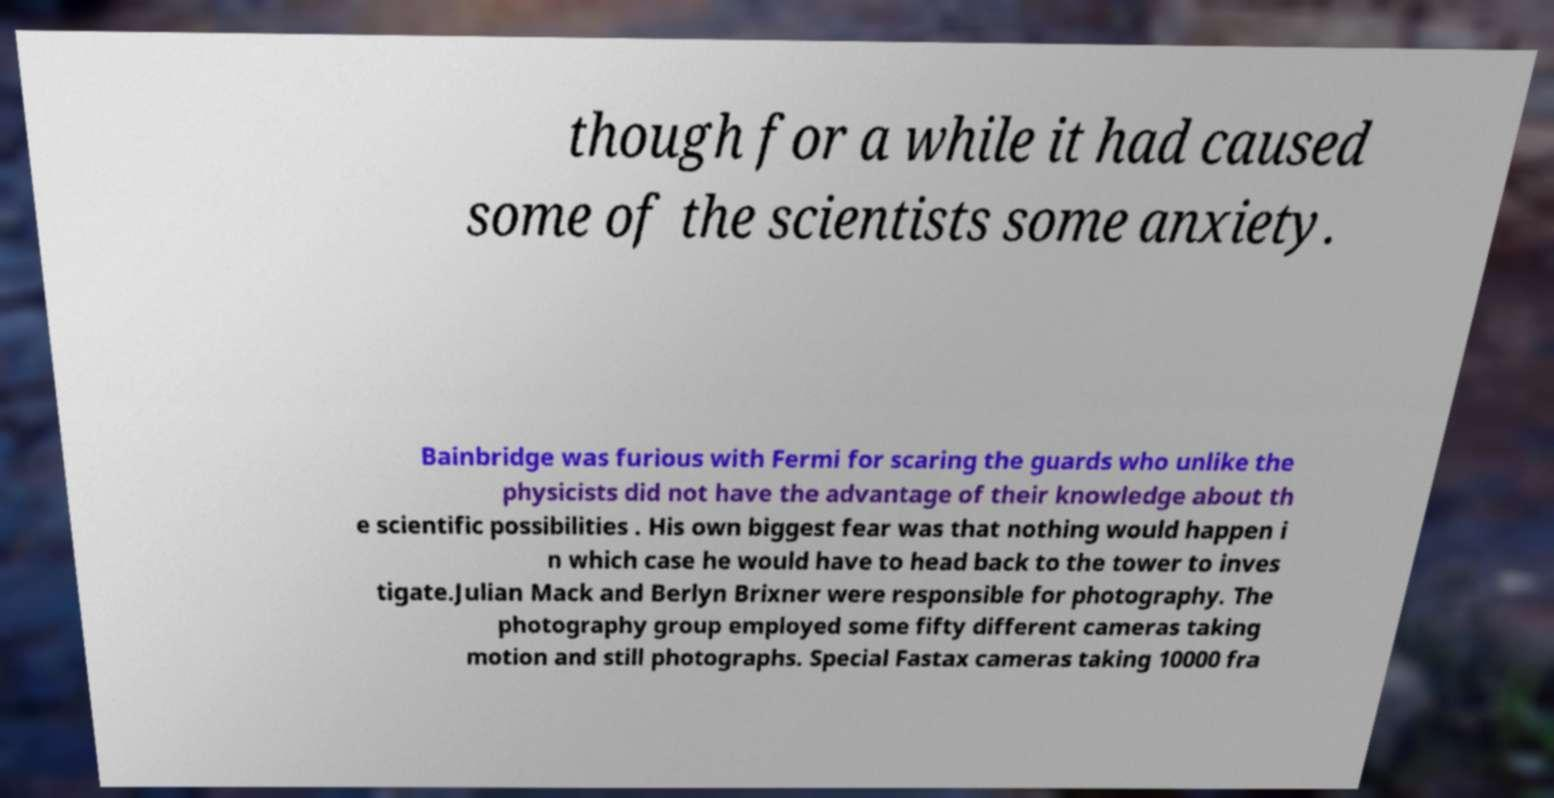Please identify and transcribe the text found in this image. though for a while it had caused some of the scientists some anxiety. Bainbridge was furious with Fermi for scaring the guards who unlike the physicists did not have the advantage of their knowledge about th e scientific possibilities . His own biggest fear was that nothing would happen i n which case he would have to head back to the tower to inves tigate.Julian Mack and Berlyn Brixner were responsible for photography. The photography group employed some fifty different cameras taking motion and still photographs. Special Fastax cameras taking 10000 fra 